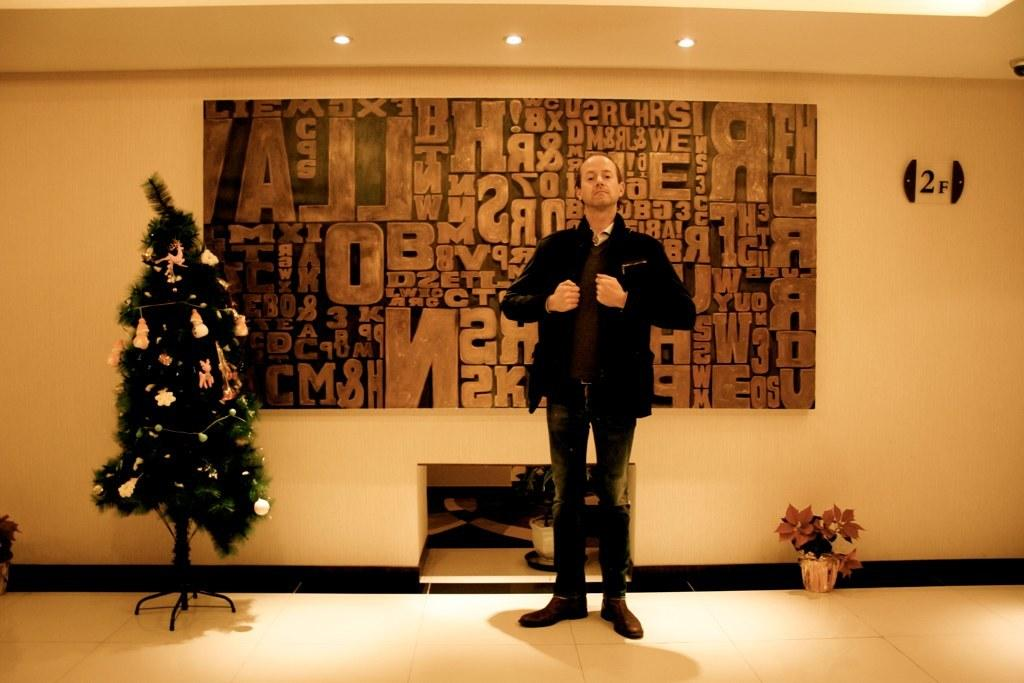What is the main subject of the image? There is a person standing in the image. What is the person wearing? The person is wearing a jacket. What can be seen on the wall in the image? There is a poster of alphabets on the wall in the image. What seasonal decoration is present in the image? There is a decorated Christmas tree in the image. What type of sofa can be seen in the image? There is no sofa present in the image. What is the person's need for the alphabet poster in the image? The image does not provide information about the person's need for the alphabet poster, as it only shows the poster on the wall. 